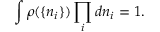Convert formula to latex. <formula><loc_0><loc_0><loc_500><loc_500>\int \rho ( \{ n _ { i } \} ) \prod _ { i } d n _ { i } = 1 .</formula> 